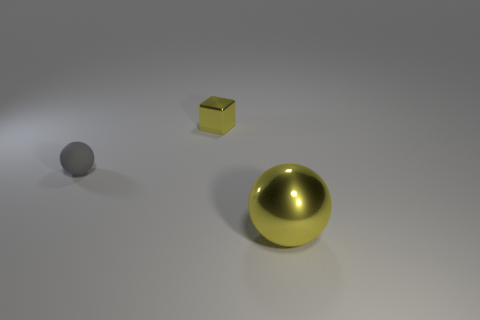Add 2 gray matte balls. How many objects exist? 5 Subtract all balls. How many objects are left? 1 Subtract all tiny red spheres. Subtract all small balls. How many objects are left? 2 Add 2 small blocks. How many small blocks are left? 3 Add 3 large green balls. How many large green balls exist? 3 Subtract 0 blue cubes. How many objects are left? 3 